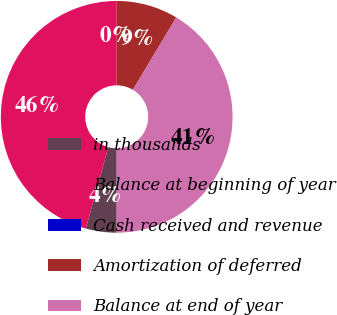Convert chart to OTSL. <chart><loc_0><loc_0><loc_500><loc_500><pie_chart><fcel>in thousands<fcel>Balance at beginning of year<fcel>Cash received and revenue<fcel>Amortization of deferred<fcel>Balance at end of year<nl><fcel>4.29%<fcel>45.71%<fcel>0.0%<fcel>8.59%<fcel>41.41%<nl></chart> 